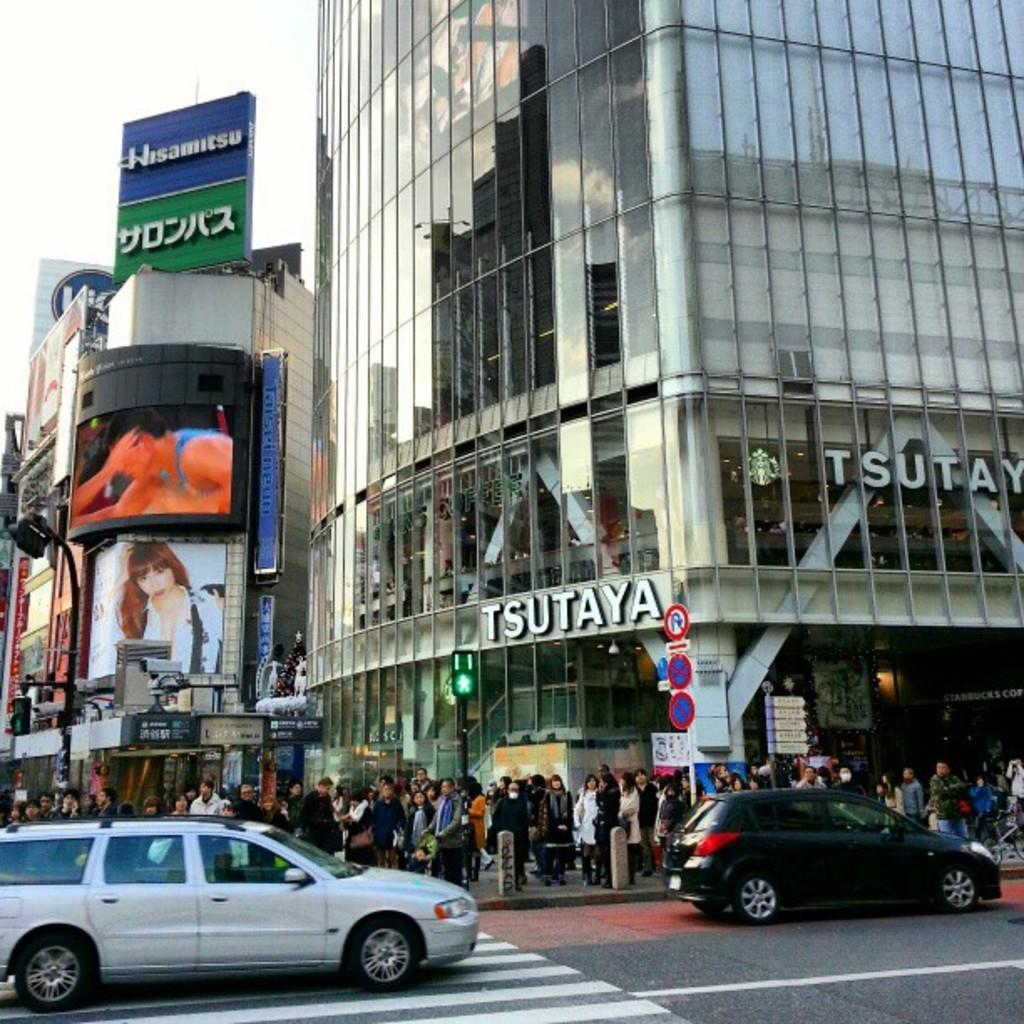Describe this image in one or two sentences. In this image we can see some buildings with windows, board and some people standing. We can also see some cars on the road and the sky. 